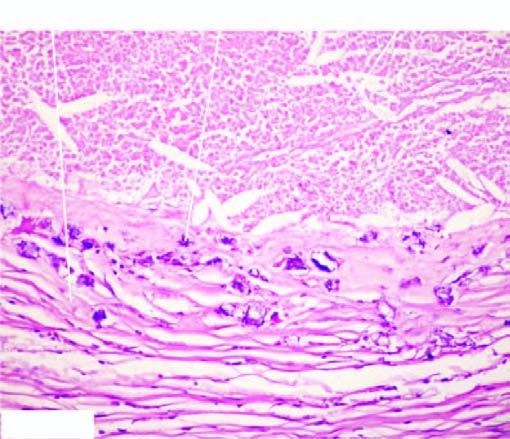does the periphery show healed granulomas?
Answer the question using a single word or phrase. Yes 